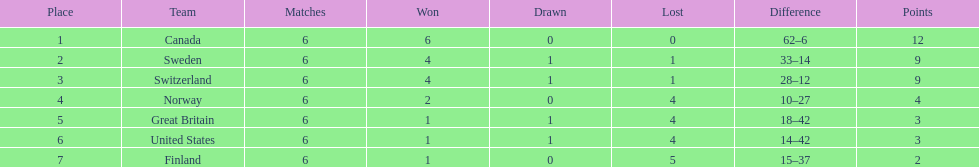Which country performed better during the 1951 world ice hockey championships, switzerland or great britain? Switzerland. 